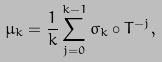Convert formula to latex. <formula><loc_0><loc_0><loc_500><loc_500>\mu _ { k } = \frac { 1 } { k } \sum _ { j = 0 } ^ { k - 1 } \sigma _ { k } \circ T ^ { - j } ,</formula> 